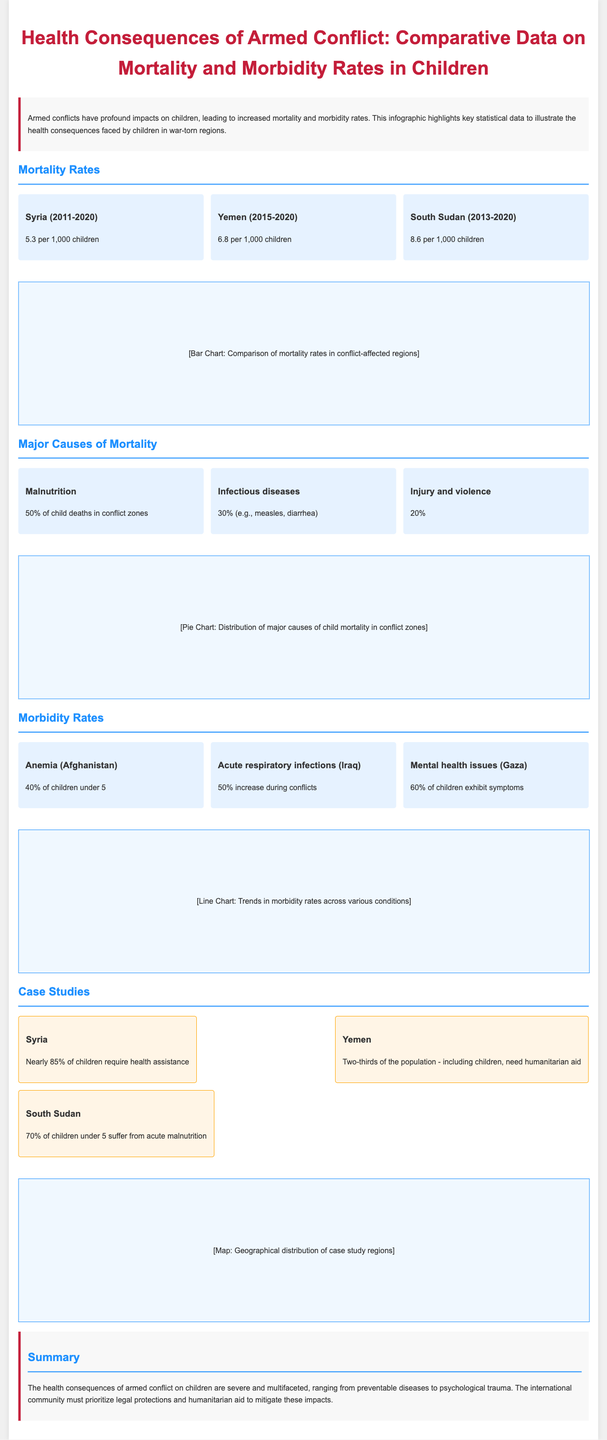What is the mortality rate in Syria from 2011-2020? The document states the mortality rate in Syria during this period is 5.3 per 1,000 children.
Answer: 5.3 per 1,000 children What percentage of child deaths in conflict zones are due to malnutrition? The document indicates that 50% of child deaths in conflict zones are attributed to malnutrition.
Answer: 50% What is the morbidity rate for anemia in children under 5 in Afghanistan? The document specifies that 40% of children under 5 in Afghanistan suffer from anemia.
Answer: 40% Which country has the highest child mortality rate among the listed regions? The document shows South Sudan has the highest mortality rate at 8.6 per 1,000 children.
Answer: South Sudan What proportion of children in Gaza exhibit mental health symptoms? The document mentions that 60% of children in Gaza exhibit mental health issues.
Answer: 60% What is the primary cause of child deaths in conflict zones? The primary cause of child deaths in conflict zones is malnutrition, accounting for 50%.
Answer: Malnutrition How many children in Syria require health assistance? The document states that nearly 85% of children in Syria require health assistance.
Answer: 85% What percentage increase in acute respiratory infections occurs during conflicts in Iraq? The document indicates there is a 50% increase in acute respiratory infections during conflicts in Iraq.
Answer: 50% Which conflict-affected region needs humanitarian aid for two-thirds of its population? The document specifies that Yemen is the region where two-thirds of the population need humanitarian aid.
Answer: Yemen 